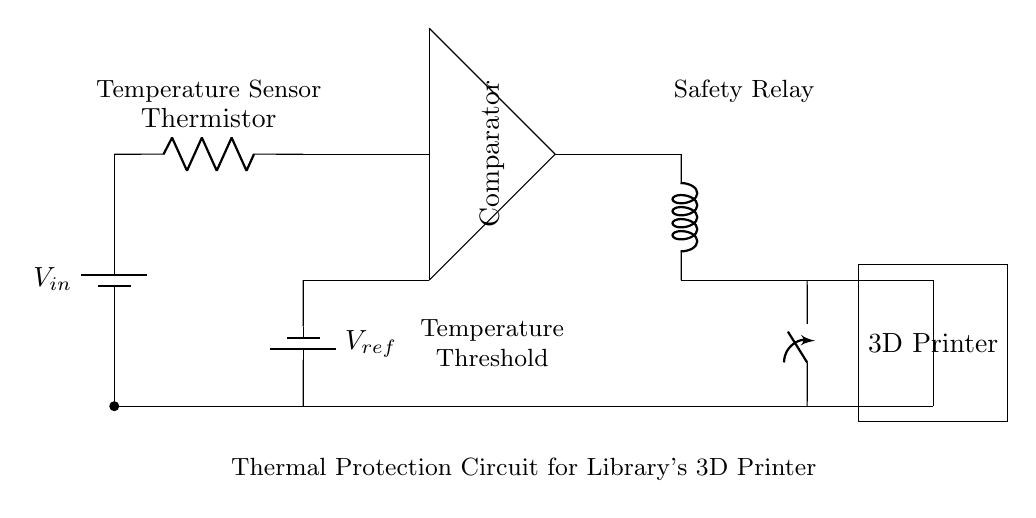What component measures temperature? The circuit includes a thermistor which is a temperature-sensitive resistor that changes resistance based on temperature. Therefore, it is the component that measures temperature in the circuit.
Answer: Thermistor What is the function of the comparator? The comparator in the circuit compares the voltage from the thermistor with a reference voltage to determine if the temperature exceeds a set threshold. It then activates the relay based on this comparison.
Answer: To compare voltages What initiates the activation of the safety relay? The safety relay is activated when the output from the comparator indicates that the temperature has surpassed the defined threshold based on the reference voltage. Thus, the relay is switched on to disconnect the load.
Answer: Comparator output What is the role of the reference voltage? The reference voltage is used as a threshold level for the comparator to determine if the temperature measured by the thermistor is safe or too high. It provides a baseline for temperature comparison.
Answer: Threshold level How is the 3D printer connected in the circuit? The 3D printer is connected as the load in the circuit. It receives power through the safety relay, which controls the current based on the comparator's output regarding the temperature condition.
Answer: As a load What happens if the temperature exceeds the threshold? If the temperature exceeds the threshold, the comparator will trigger the safety relay, which then opens the switch, disconnecting the 3D printer from the power supply to prevent overheating.
Answer: The printer is disconnected 